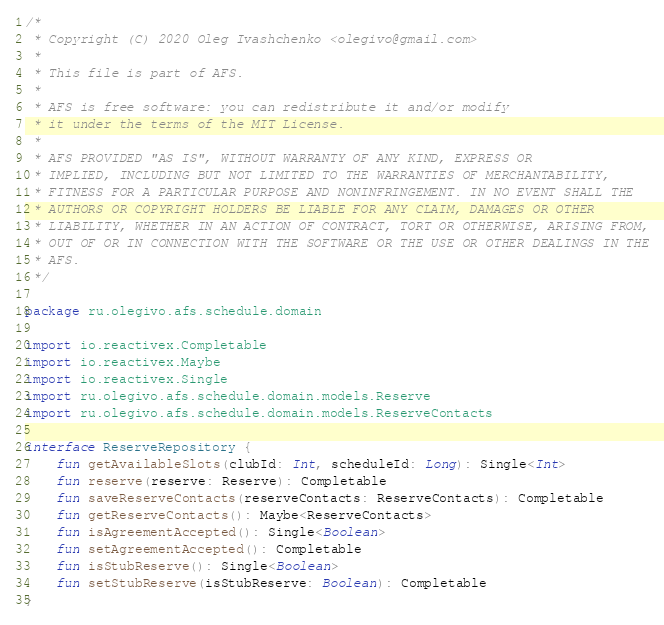<code> <loc_0><loc_0><loc_500><loc_500><_Kotlin_>/*
 * Copyright (C) 2020 Oleg Ivashchenko <olegivo@gmail.com>
 *
 * This file is part of AFS.
 *
 * AFS is free software: you can redistribute it and/or modify
 * it under the terms of the MIT License.
 *
 * AFS PROVIDED "AS IS", WITHOUT WARRANTY OF ANY KIND, EXPRESS OR
 * IMPLIED, INCLUDING BUT NOT LIMITED TO THE WARRANTIES OF MERCHANTABILITY,
 * FITNESS FOR A PARTICULAR PURPOSE AND NONINFRINGEMENT. IN NO EVENT SHALL THE
 * AUTHORS OR COPYRIGHT HOLDERS BE LIABLE FOR ANY CLAIM, DAMAGES OR OTHER
 * LIABILITY, WHETHER IN AN ACTION OF CONTRACT, TORT OR OTHERWISE, ARISING FROM,
 * OUT OF OR IN CONNECTION WITH THE SOFTWARE OR THE USE OR OTHER DEALINGS IN THE
 * AFS.
 */

package ru.olegivo.afs.schedule.domain

import io.reactivex.Completable
import io.reactivex.Maybe
import io.reactivex.Single
import ru.olegivo.afs.schedule.domain.models.Reserve
import ru.olegivo.afs.schedule.domain.models.ReserveContacts

interface ReserveRepository {
    fun getAvailableSlots(clubId: Int, scheduleId: Long): Single<Int>
    fun reserve(reserve: Reserve): Completable
    fun saveReserveContacts(reserveContacts: ReserveContacts): Completable
    fun getReserveContacts(): Maybe<ReserveContacts>
    fun isAgreementAccepted(): Single<Boolean>
    fun setAgreementAccepted(): Completable
    fun isStubReserve(): Single<Boolean>
    fun setStubReserve(isStubReserve: Boolean): Completable
}
</code> 